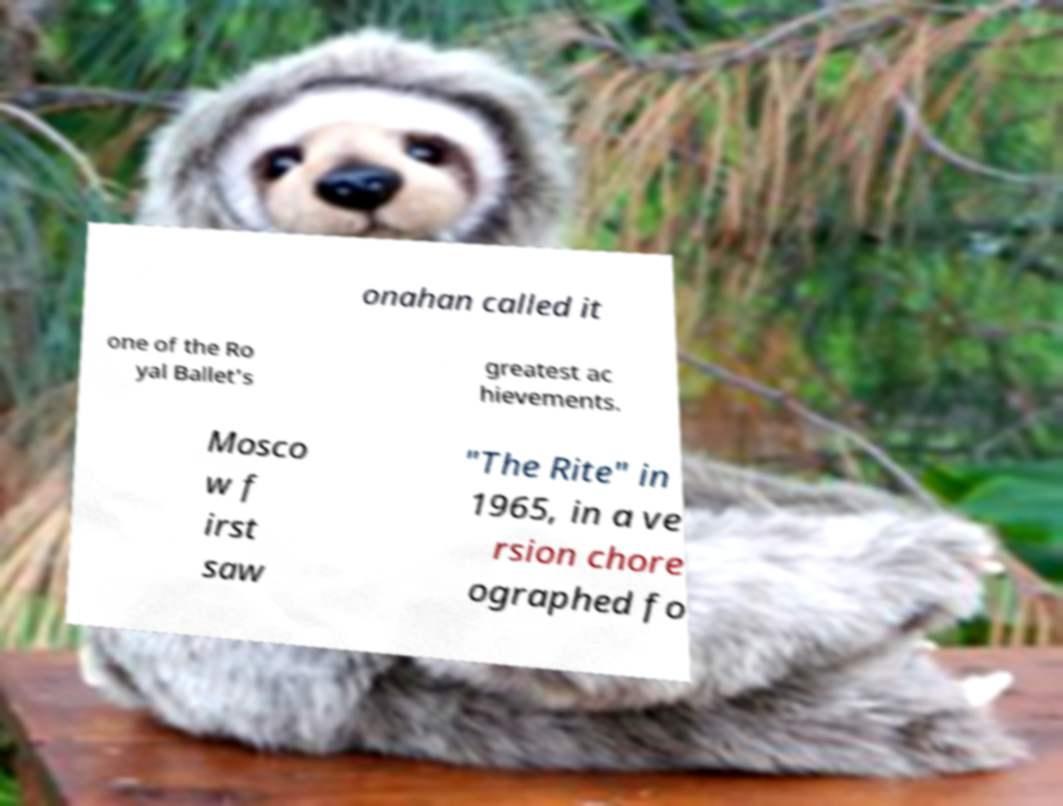There's text embedded in this image that I need extracted. Can you transcribe it verbatim? onahan called it one of the Ro yal Ballet's greatest ac hievements. Mosco w f irst saw "The Rite" in 1965, in a ve rsion chore ographed fo 